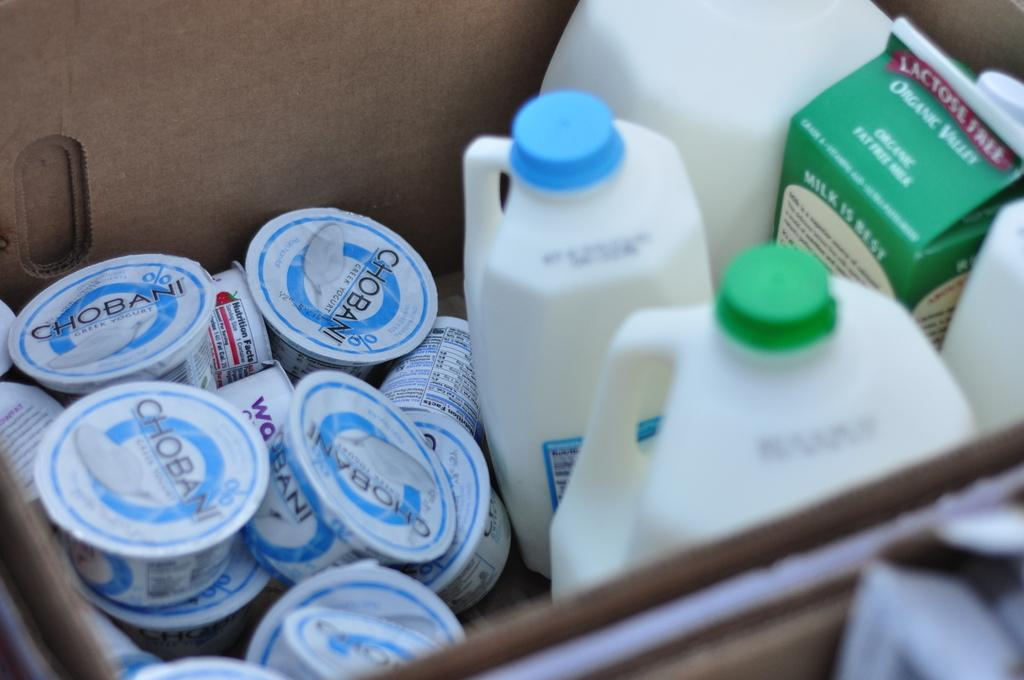What type of containers can be seen in the image? There are small boxes, cans, and tetra packs in the image. How are the tetra packs arranged in relation to the small boxes? The tetra packs are inside the small boxes. What type of stitch is used to cover the cans in the image? There is no mention of any stitching or covering on the cans in the image. 